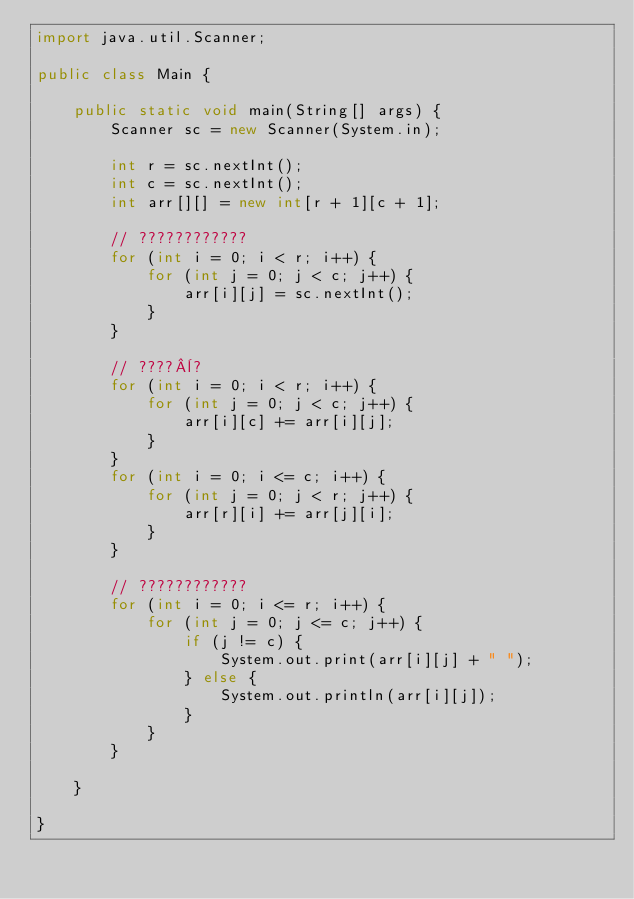<code> <loc_0><loc_0><loc_500><loc_500><_Java_>import java.util.Scanner;

public class Main {

	public static void main(String[] args) {
		Scanner sc = new Scanner(System.in);

		int r = sc.nextInt();
		int c = sc.nextInt();
		int arr[][] = new int[r + 1][c + 1];

		// ????????????
		for (int i = 0; i < r; i++) {
			for (int j = 0; j < c; j++) {
				arr[i][j] = sc.nextInt();
			}
		}

		// ????¨?
		for (int i = 0; i < r; i++) {
			for (int j = 0; j < c; j++) {
				arr[i][c] += arr[i][j];
			}
		}
		for (int i = 0; i <= c; i++) {
			for (int j = 0; j < r; j++) {
				arr[r][i] += arr[j][i];
			}
		}

		// ????????????
		for (int i = 0; i <= r; i++) {
			for (int j = 0; j <= c; j++) {
				if (j != c) {
					System.out.print(arr[i][j] + " ");
				} else {
					System.out.println(arr[i][j]);
				}
			}
		}

	}

}</code> 